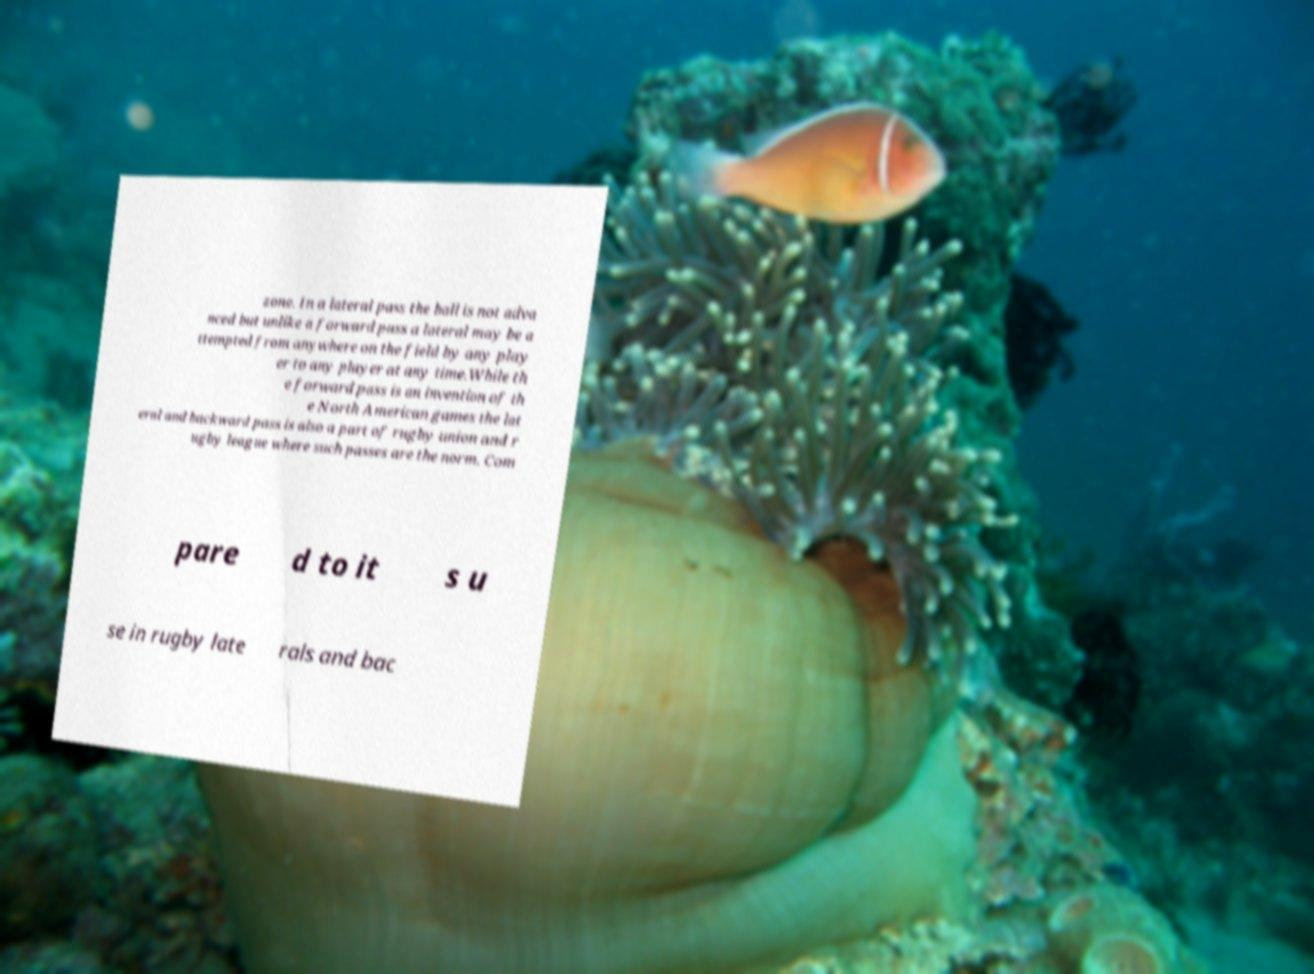Can you accurately transcribe the text from the provided image for me? zone. In a lateral pass the ball is not adva nced but unlike a forward pass a lateral may be a ttempted from anywhere on the field by any play er to any player at any time.While th e forward pass is an invention of th e North American games the lat eral and backward pass is also a part of rugby union and r ugby league where such passes are the norm. Com pare d to it s u se in rugby late rals and bac 